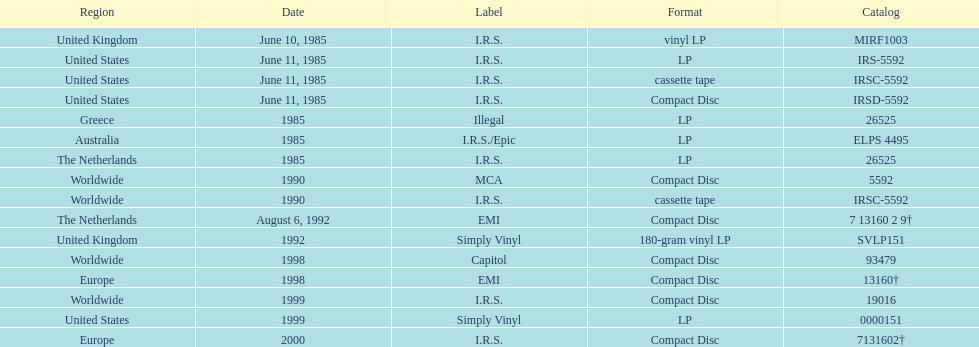In which country or region can the most releases be found? Worldwide. 